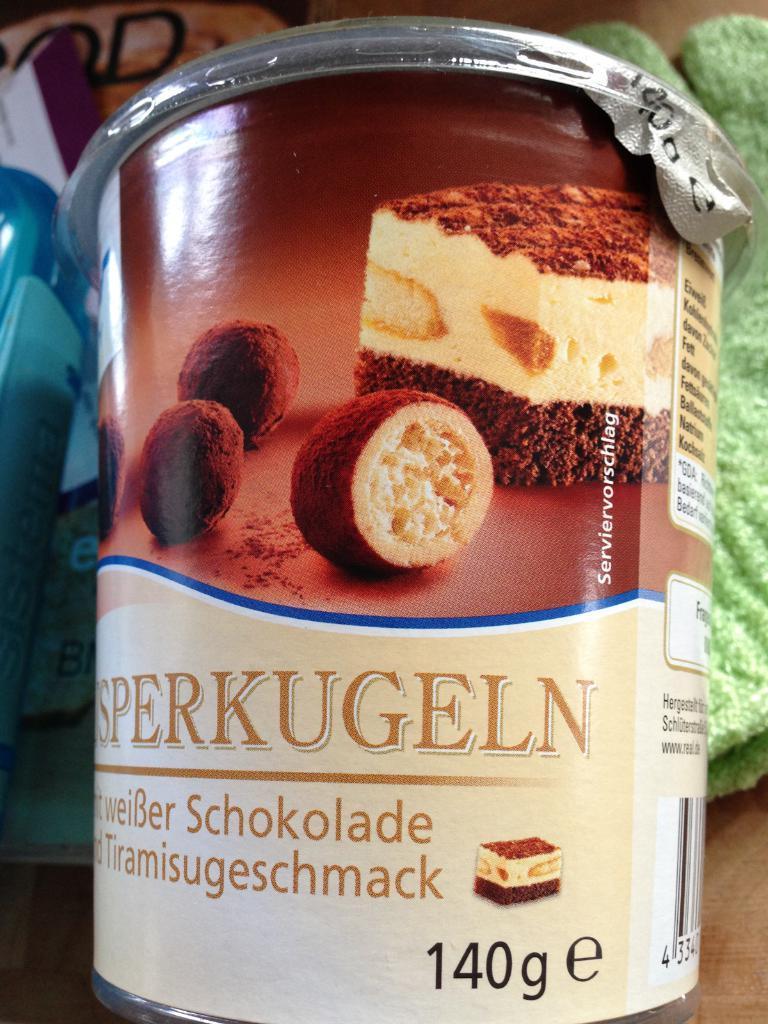Could you give a brief overview of what you see in this image? In this given picture, we can see a floor and a food item tin next towards the left in the middle, we can see few objects. 